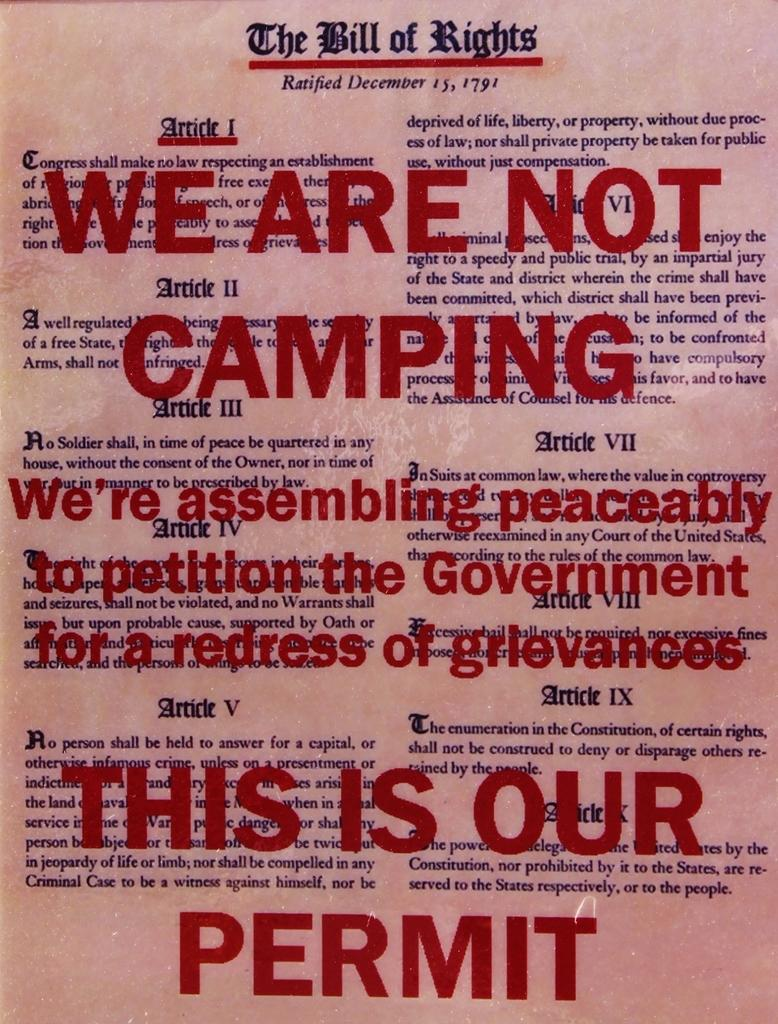<image>
Relay a brief, clear account of the picture shown. Poster for The Bill of Rights showing "This is our Permit" in red wording. 